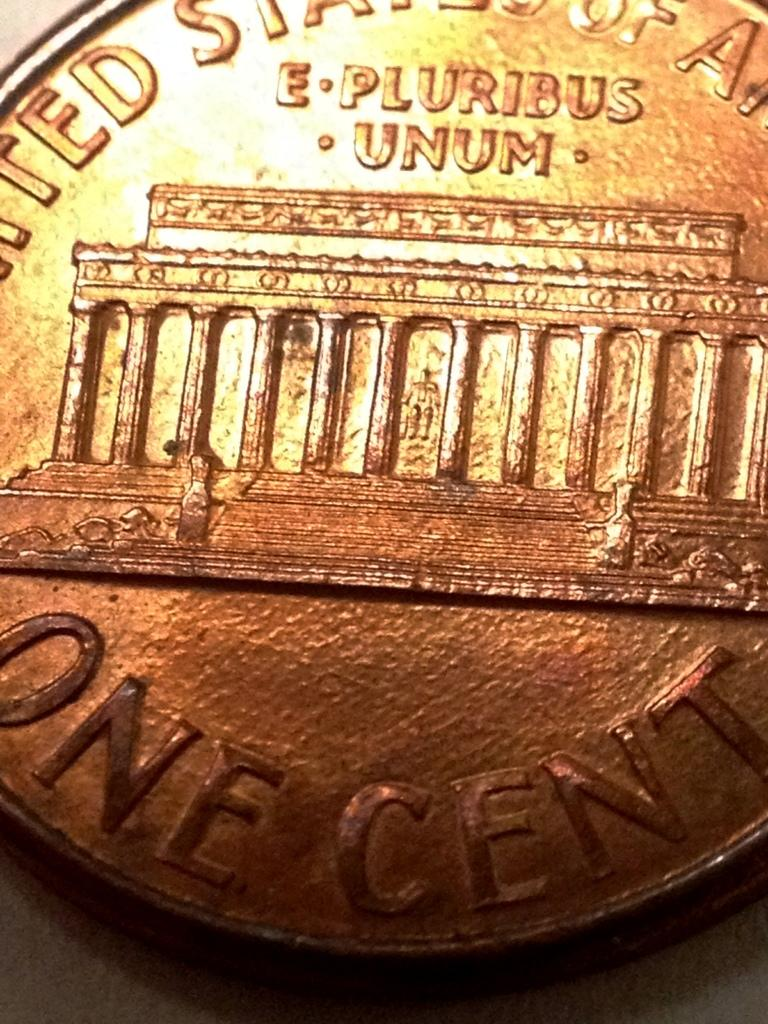<image>
Create a compact narrative representing the image presented. The view of the back of this one cent coin is very close up. 